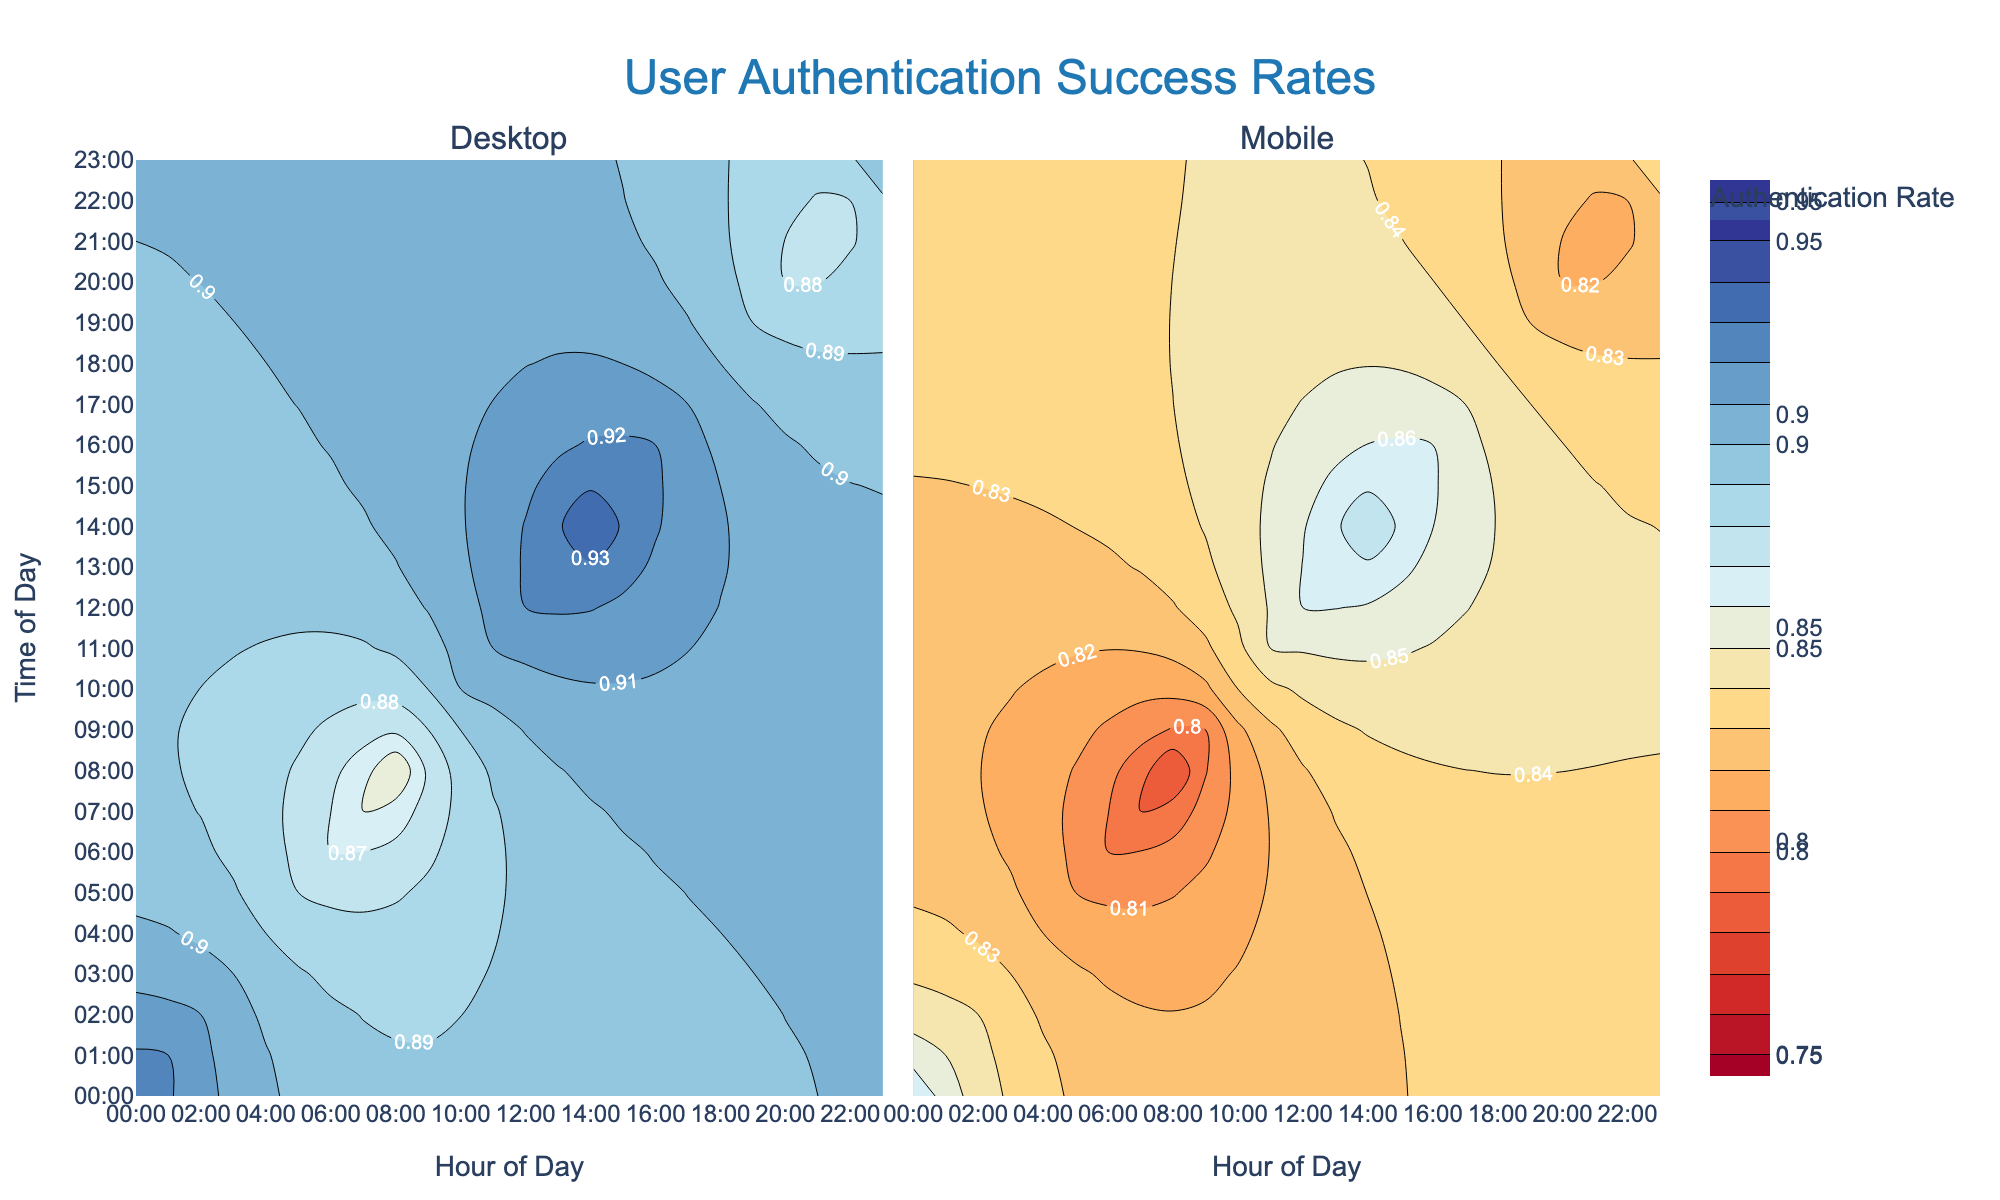What's the overall title of the figure? The overall title is found at the top center of the figure, usually in larger and bold text. It describes the main topic or focus of the plot. In this figure, the title is "User Authentication Success Rates."
Answer: User Authentication Success Rates Do both Desktop and Mobile devices show the highest authentication rates at the same time? Look at the contour plots for both Desktop and Mobile devices and identify the times with the highest rate labels. For both devices, the highest rates are labeled at 00:00 and 13:00.
Answer: Yes At what time of day is the Mobile device's authentication rate lowest? Refer to the Mobile contour plot and identify where the lowest authentication rate labels are placed. According to the plot, the lowest rate for Mobile devices is at 07:00.
Answer: 07:00 Does the Desktop authentication rate ever go below 0.88? Check the contour labels and color gradients in the Desktop plot to see if there are any ranges indicated below the 0.88 mark. The Desktop authentication rate never goes below 0.88.
Answer: No What is the range of authentication rates shown for Desktop devices? Identify the lowest and highest labeled authentication rates in the Desktop contour plot. The labels range from 0.88 to 0.94.
Answer: 0.88 to 0.94 Which device type has a wider range of authentication rates? Compare the lowest and highest authentication rates in both contour plots. Desktop ranges from 0.88 to 0.94, and Mobile ranges from 0.78 to 0.88. This calculation indicates Mobile has a wider range.
Answer: Mobile What time of day sees a significant increase in authentication rates for both Desktop and Mobile devices? Look for notable upward trends in both plots. Both Desktop and Mobile show a significant increase starting at 08:00 and peaking around 12:00.
Answer: 08:00 to 12:00 How does the authentication rate at 15:00 compare between Desktop and Mobile devices? Check the specific time 15:00 on both plots and compare the labeled rates. The rate for Desktop is higher at 0.93, while for Mobile, it is 0.87.
Answer: Desktop is higher Is there any time when both devices have the same authentication rate? Compare the contour labels for both Desktop and Mobile across all times to identify any matching rates. None of the times have matching rates between the two devices.
Answer: No 